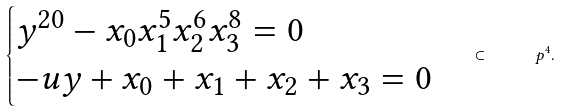Convert formula to latex. <formula><loc_0><loc_0><loc_500><loc_500>\begin{cases} y ^ { 2 0 } - x _ { 0 } x _ { 1 } ^ { 5 } x _ { 2 } ^ { 6 } x _ { 3 } ^ { 8 } = 0 \\ - u y + x _ { 0 } + x _ { 1 } + x _ { 2 } + x _ { 3 } = 0 \end{cases} \subset \quad \ p ^ { 4 } .</formula> 